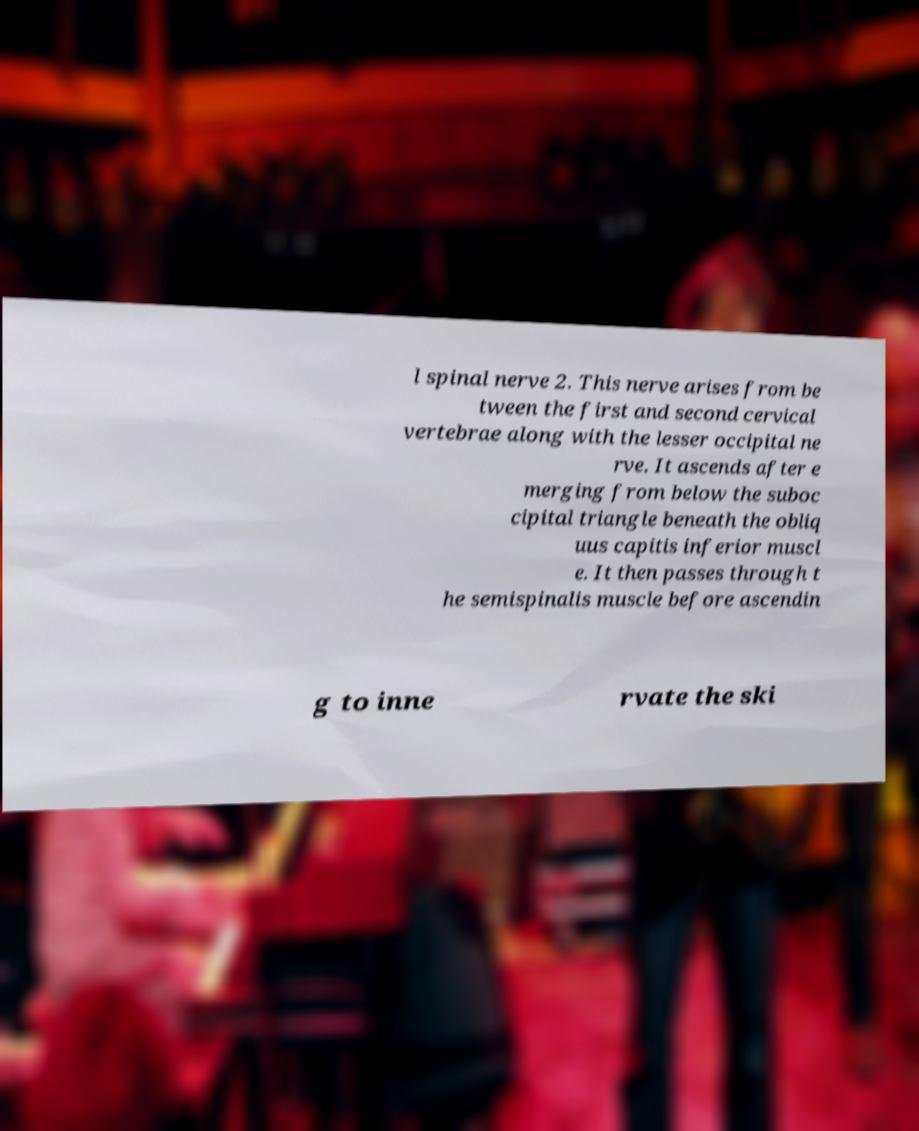For documentation purposes, I need the text within this image transcribed. Could you provide that? l spinal nerve 2. This nerve arises from be tween the first and second cervical vertebrae along with the lesser occipital ne rve. It ascends after e merging from below the suboc cipital triangle beneath the obliq uus capitis inferior muscl e. It then passes through t he semispinalis muscle before ascendin g to inne rvate the ski 